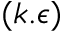Convert formula to latex. <formula><loc_0><loc_0><loc_500><loc_500>( k . \epsilon )</formula> 